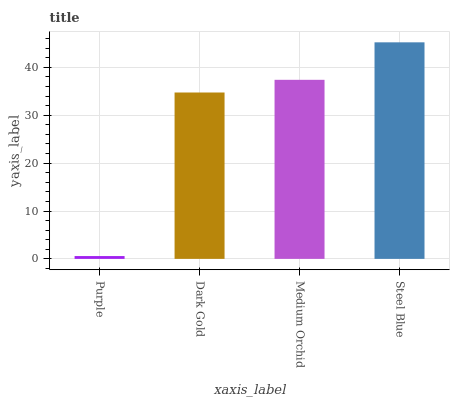Is Purple the minimum?
Answer yes or no. Yes. Is Steel Blue the maximum?
Answer yes or no. Yes. Is Dark Gold the minimum?
Answer yes or no. No. Is Dark Gold the maximum?
Answer yes or no. No. Is Dark Gold greater than Purple?
Answer yes or no. Yes. Is Purple less than Dark Gold?
Answer yes or no. Yes. Is Purple greater than Dark Gold?
Answer yes or no. No. Is Dark Gold less than Purple?
Answer yes or no. No. Is Medium Orchid the high median?
Answer yes or no. Yes. Is Dark Gold the low median?
Answer yes or no. Yes. Is Dark Gold the high median?
Answer yes or no. No. Is Purple the low median?
Answer yes or no. No. 